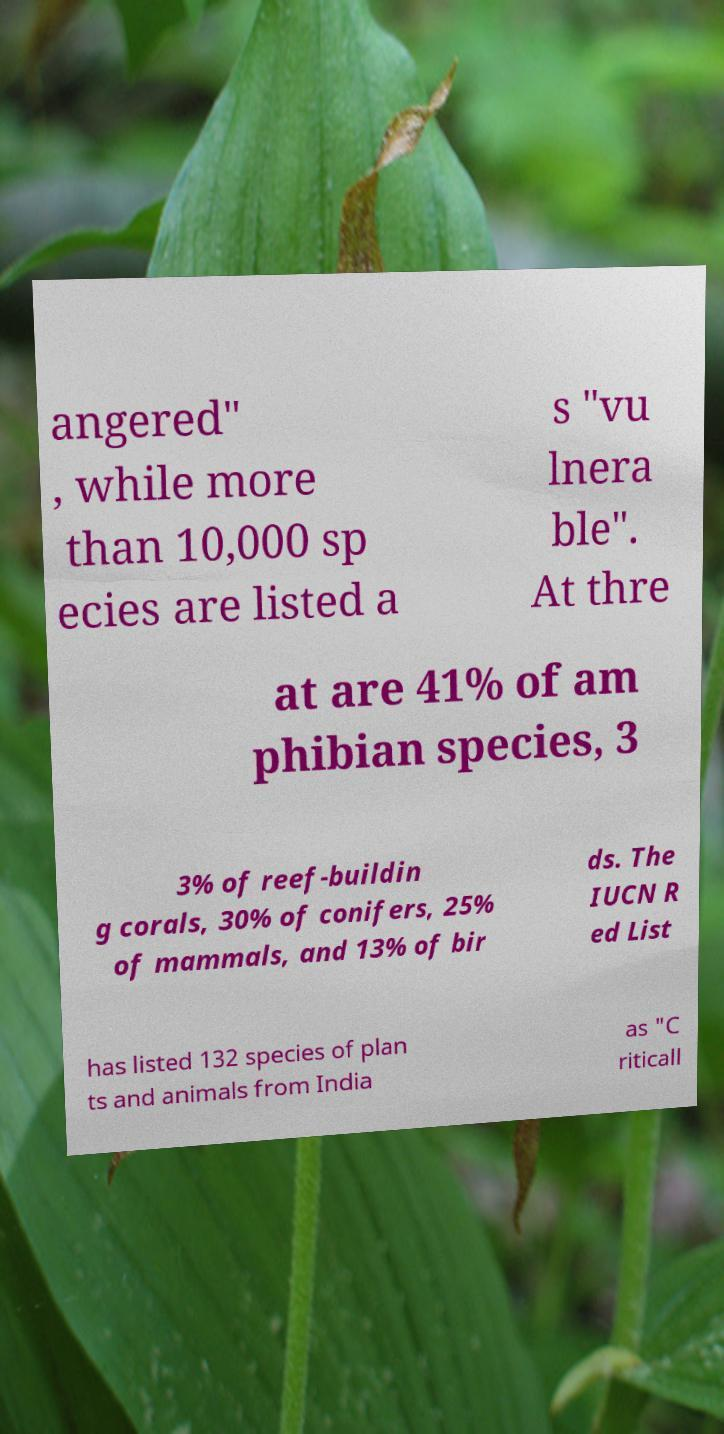Could you extract and type out the text from this image? angered" , while more than 10,000 sp ecies are listed a s "vu lnera ble". At thre at are 41% of am phibian species, 3 3% of reef-buildin g corals, 30% of conifers, 25% of mammals, and 13% of bir ds. The IUCN R ed List has listed 132 species of plan ts and animals from India as "C riticall 